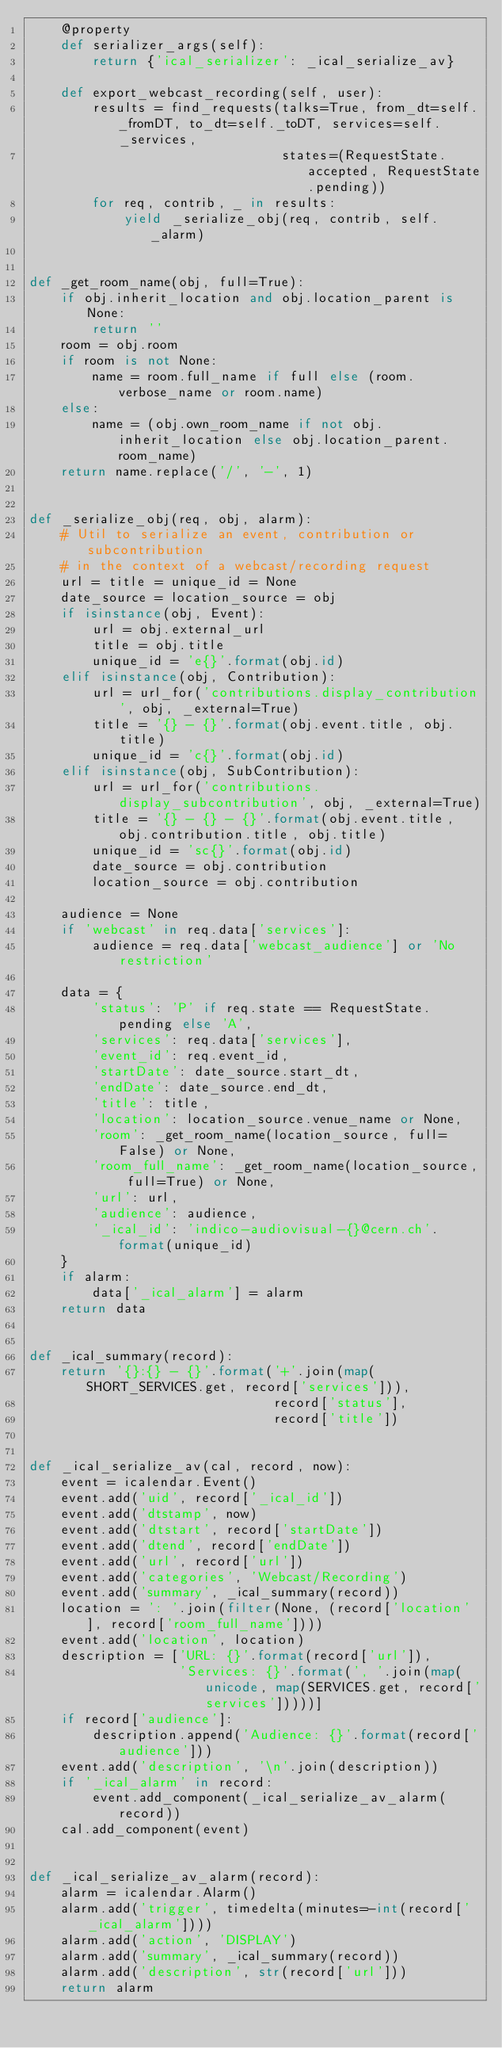Convert code to text. <code><loc_0><loc_0><loc_500><loc_500><_Python_>    @property
    def serializer_args(self):
        return {'ical_serializer': _ical_serialize_av}

    def export_webcast_recording(self, user):
        results = find_requests(talks=True, from_dt=self._fromDT, to_dt=self._toDT, services=self._services,
                                states=(RequestState.accepted, RequestState.pending))
        for req, contrib, _ in results:
            yield _serialize_obj(req, contrib, self._alarm)


def _get_room_name(obj, full=True):
    if obj.inherit_location and obj.location_parent is None:
        return ''
    room = obj.room
    if room is not None:
        name = room.full_name if full else (room.verbose_name or room.name)
    else:
        name = (obj.own_room_name if not obj.inherit_location else obj.location_parent.room_name)
    return name.replace('/', '-', 1)


def _serialize_obj(req, obj, alarm):
    # Util to serialize an event, contribution or subcontribution
    # in the context of a webcast/recording request
    url = title = unique_id = None
    date_source = location_source = obj
    if isinstance(obj, Event):
        url = obj.external_url
        title = obj.title
        unique_id = 'e{}'.format(obj.id)
    elif isinstance(obj, Contribution):
        url = url_for('contributions.display_contribution', obj, _external=True)
        title = '{} - {}'.format(obj.event.title, obj.title)
        unique_id = 'c{}'.format(obj.id)
    elif isinstance(obj, SubContribution):
        url = url_for('contributions.display_subcontribution', obj, _external=True)
        title = '{} - {} - {}'.format(obj.event.title, obj.contribution.title, obj.title)
        unique_id = 'sc{}'.format(obj.id)
        date_source = obj.contribution
        location_source = obj.contribution

    audience = None
    if 'webcast' in req.data['services']:
        audience = req.data['webcast_audience'] or 'No restriction'

    data = {
        'status': 'P' if req.state == RequestState.pending else 'A',
        'services': req.data['services'],
        'event_id': req.event_id,
        'startDate': date_source.start_dt,
        'endDate': date_source.end_dt,
        'title': title,
        'location': location_source.venue_name or None,
        'room': _get_room_name(location_source, full=False) or None,
        'room_full_name': _get_room_name(location_source, full=True) or None,
        'url': url,
        'audience': audience,
        '_ical_id': 'indico-audiovisual-{}@cern.ch'.format(unique_id)
    }
    if alarm:
        data['_ical_alarm'] = alarm
    return data


def _ical_summary(record):
    return '{}:{} - {}'.format('+'.join(map(SHORT_SERVICES.get, record['services'])),
                               record['status'],
                               record['title'])


def _ical_serialize_av(cal, record, now):
    event = icalendar.Event()
    event.add('uid', record['_ical_id'])
    event.add('dtstamp', now)
    event.add('dtstart', record['startDate'])
    event.add('dtend', record['endDate'])
    event.add('url', record['url'])
    event.add('categories', 'Webcast/Recording')
    event.add('summary', _ical_summary(record))
    location = ': '.join(filter(None, (record['location'], record['room_full_name'])))
    event.add('location', location)
    description = ['URL: {}'.format(record['url']),
                   'Services: {}'.format(', '.join(map(unicode, map(SERVICES.get, record['services']))))]
    if record['audience']:
        description.append('Audience: {}'.format(record['audience']))
    event.add('description', '\n'.join(description))
    if '_ical_alarm' in record:
        event.add_component(_ical_serialize_av_alarm(record))
    cal.add_component(event)


def _ical_serialize_av_alarm(record):
    alarm = icalendar.Alarm()
    alarm.add('trigger', timedelta(minutes=-int(record['_ical_alarm'])))
    alarm.add('action', 'DISPLAY')
    alarm.add('summary', _ical_summary(record))
    alarm.add('description', str(record['url']))
    return alarm
</code> 